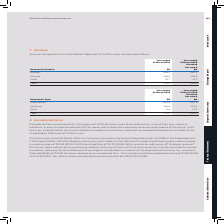According to Sophos Group's financial document, What was the amount of Total revenue in 2019? According to the financial document, 710.6 (in millions). The relevant text states: "Total 710.6 639.0..." Also, What was the amount of Other in 2019? According to the financial document, 33.7 (in millions). The relevant text states: "Other 33.7 30.7..." Also, What are the product types analyzed in the table which contribute to the Revenue recognised in the Consolidated Statement of Profit or Loss? The document contains multiple relevant values: Network, Enduser, Other. From the document: "Network 328.5 316.5 Enduser 348.4 291.8 Other 33.7 30.7..." Additionally, In which year was the amount of Other larger? According to the financial document, 2019. The relevant text states: "Year-ended 31 March 2019..." Also, can you calculate: What was the change in Enduser in 2019 from 2018? Based on the calculation: 348.4-291.8, the result is 56.6 (in millions). This is based on the information: "Enduser 348.4 291.8 Enduser 348.4 291.8..." The key data points involved are: 291.8, 348.4. Also, can you calculate: What was the percentage change in Enduser in 2019 from 2018? To answer this question, I need to perform calculations using the financial data. The calculation is: (348.4-291.8)/291.8, which equals 19.4 (percentage). This is based on the information: "Enduser 348.4 291.8 Enduser 348.4 291.8..." The key data points involved are: 291.8, 348.4. 